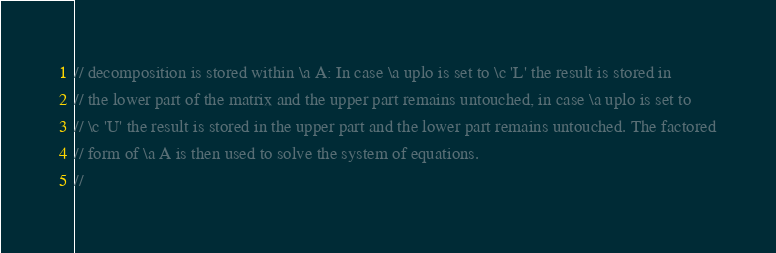<code> <loc_0><loc_0><loc_500><loc_500><_C_>// decomposition is stored within \a A: In case \a uplo is set to \c 'L' the result is stored in
// the lower part of the matrix and the upper part remains untouched, in case \a uplo is set to
// \c 'U' the result is stored in the upper part and the lower part remains untouched. The factored
// form of \a A is then used to solve the system of equations.
//</code> 